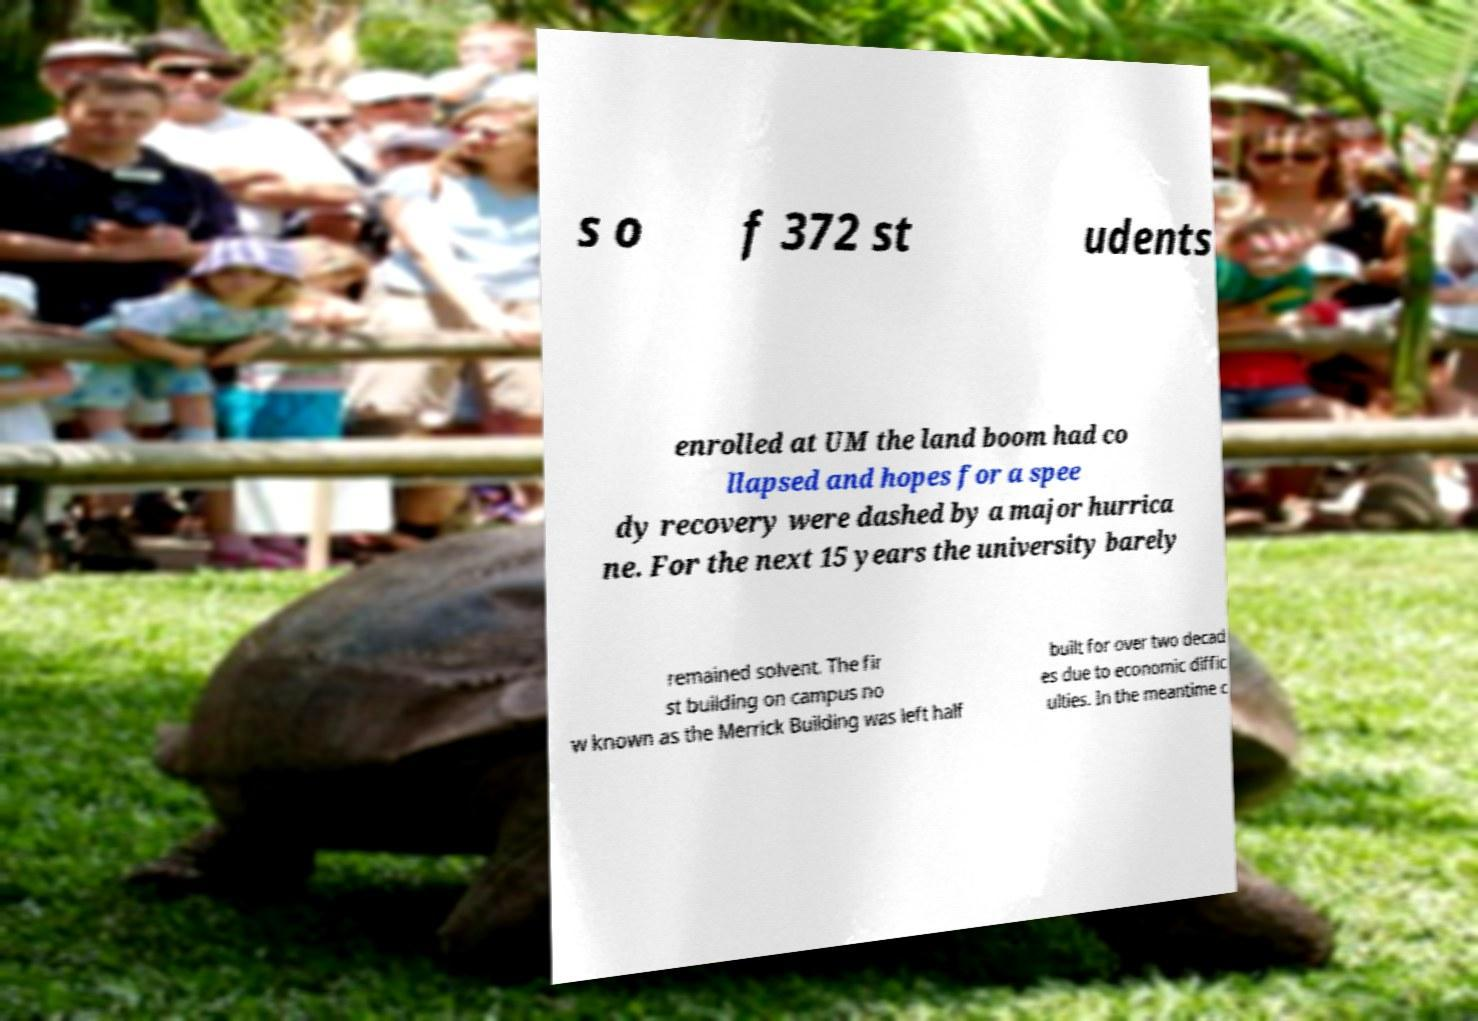For documentation purposes, I need the text within this image transcribed. Could you provide that? s o f 372 st udents enrolled at UM the land boom had co llapsed and hopes for a spee dy recovery were dashed by a major hurrica ne. For the next 15 years the university barely remained solvent. The fir st building on campus no w known as the Merrick Building was left half built for over two decad es due to economic diffic ulties. In the meantime c 